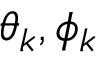<formula> <loc_0><loc_0><loc_500><loc_500>\theta _ { k } , \phi _ { k }</formula> 